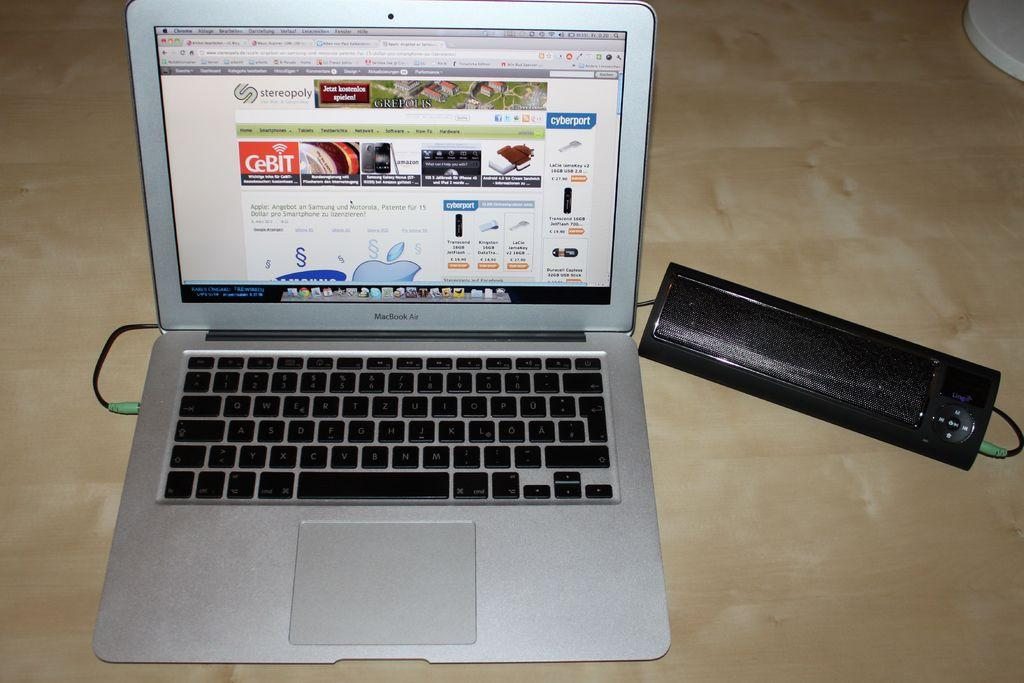<image>
Describe the image concisely. A MacBook Air brand laptop is open and powered on. 